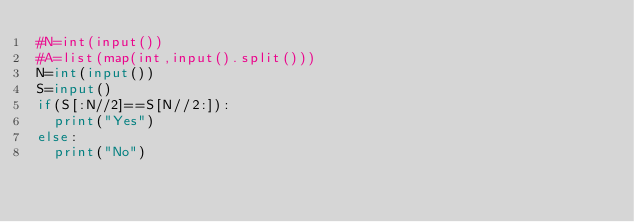Convert code to text. <code><loc_0><loc_0><loc_500><loc_500><_Python_>#N=int(input())
#A=list(map(int,input().split()))
N=int(input())
S=input()
if(S[:N//2]==S[N//2:]):
	print("Yes")
else:
	print("No")	
</code> 